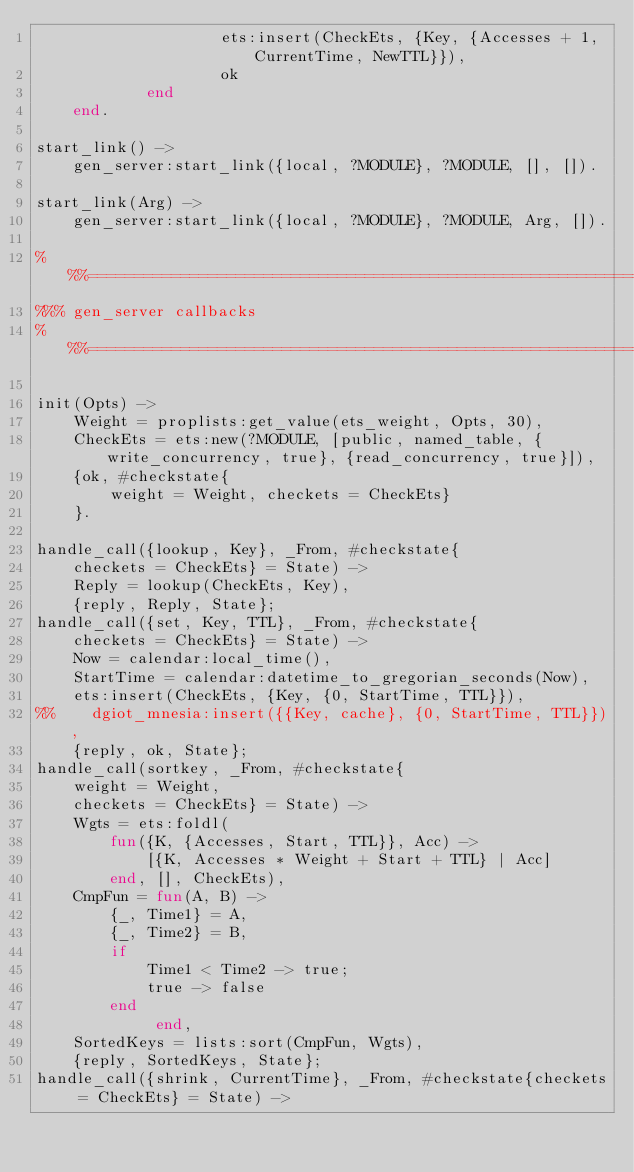Convert code to text. <code><loc_0><loc_0><loc_500><loc_500><_Erlang_>                    ets:insert(CheckEts, {Key, {Accesses + 1, CurrentTime, NewTTL}}),
                    ok
            end
    end.

start_link() ->
    gen_server:start_link({local, ?MODULE}, ?MODULE, [], []).

start_link(Arg) ->
    gen_server:start_link({local, ?MODULE}, ?MODULE, Arg, []).

%%%===================================================================
%%% gen_server callbacks
%%%===================================================================

init(Opts) ->
    Weight = proplists:get_value(ets_weight, Opts, 30),
    CheckEts = ets:new(?MODULE, [public, named_table, {write_concurrency, true}, {read_concurrency, true}]),
    {ok, #checkstate{
        weight = Weight, checkets = CheckEts}
    }.

handle_call({lookup, Key}, _From, #checkstate{
    checkets = CheckEts} = State) ->
    Reply = lookup(CheckEts, Key),
    {reply, Reply, State};
handle_call({set, Key, TTL}, _From, #checkstate{
    checkets = CheckEts} = State) ->
    Now = calendar:local_time(),
    StartTime = calendar:datetime_to_gregorian_seconds(Now),
    ets:insert(CheckEts, {Key, {0, StartTime, TTL}}),
%%    dgiot_mnesia:insert({{Key, cache}, {0, StartTime, TTL}}),
    {reply, ok, State};
handle_call(sortkey, _From, #checkstate{
    weight = Weight,
    checkets = CheckEts} = State) ->
    Wgts = ets:foldl(
        fun({K, {Accesses, Start, TTL}}, Acc) ->
            [{K, Accesses * Weight + Start + TTL} | Acc]
        end, [], CheckEts),
    CmpFun = fun(A, B) ->
        {_, Time1} = A,
        {_, Time2} = B,
        if
            Time1 < Time2 -> true;
            true -> false
        end
             end,
    SortedKeys = lists:sort(CmpFun, Wgts),
    {reply, SortedKeys, State};
handle_call({shrink, CurrentTime}, _From, #checkstate{checkets = CheckEts} = State) -></code> 